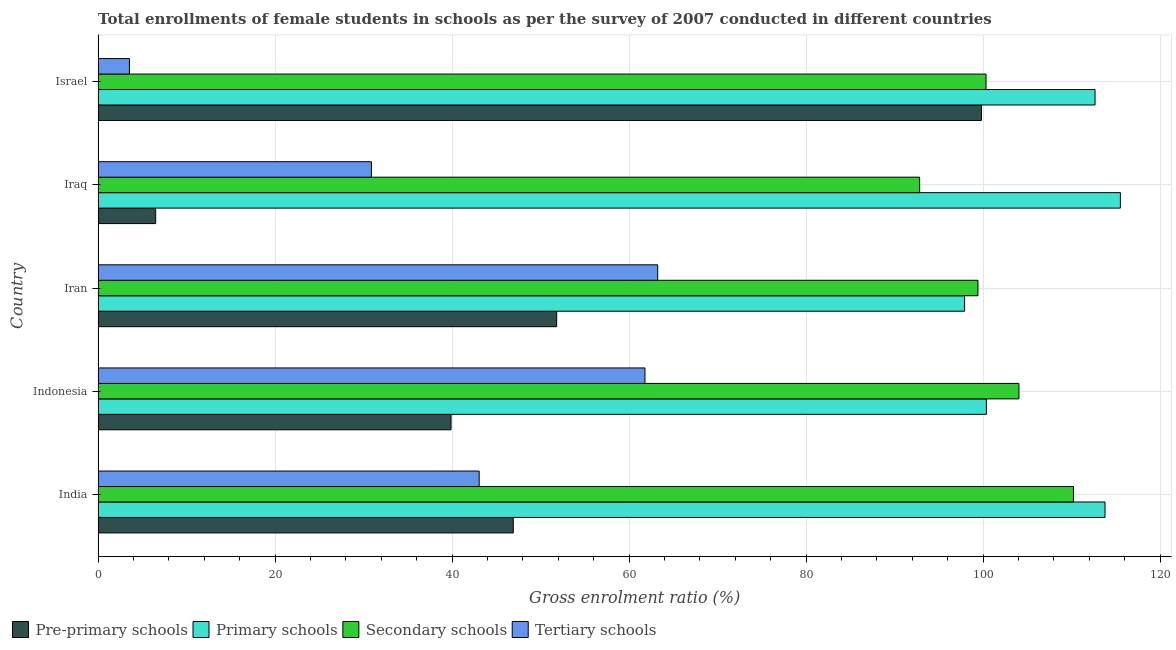Are the number of bars per tick equal to the number of legend labels?
Provide a succinct answer. Yes. Are the number of bars on each tick of the Y-axis equal?
Ensure brevity in your answer.  Yes. How many bars are there on the 2nd tick from the top?
Your response must be concise. 4. What is the label of the 4th group of bars from the top?
Offer a terse response. Indonesia. In how many cases, is the number of bars for a given country not equal to the number of legend labels?
Offer a terse response. 0. What is the gross enrolment ratio(female) in tertiary schools in Iran?
Keep it short and to the point. 63.23. Across all countries, what is the maximum gross enrolment ratio(female) in primary schools?
Your answer should be very brief. 115.51. Across all countries, what is the minimum gross enrolment ratio(female) in tertiary schools?
Offer a terse response. 3.54. In which country was the gross enrolment ratio(female) in primary schools maximum?
Ensure brevity in your answer.  Iraq. What is the total gross enrolment ratio(female) in pre-primary schools in the graph?
Give a very brief answer. 244.92. What is the difference between the gross enrolment ratio(female) in primary schools in India and that in Iran?
Ensure brevity in your answer.  15.87. What is the difference between the gross enrolment ratio(female) in pre-primary schools in Israel and the gross enrolment ratio(female) in secondary schools in Indonesia?
Offer a terse response. -4.23. What is the average gross enrolment ratio(female) in secondary schools per country?
Provide a short and direct response. 101.36. What is the difference between the gross enrolment ratio(female) in tertiary schools and gross enrolment ratio(female) in primary schools in Iraq?
Give a very brief answer. -84.63. In how many countries, is the gross enrolment ratio(female) in secondary schools greater than 80 %?
Keep it short and to the point. 5. What is the ratio of the gross enrolment ratio(female) in pre-primary schools in Indonesia to that in Iran?
Offer a terse response. 0.77. What is the difference between the highest and the second highest gross enrolment ratio(female) in pre-primary schools?
Your answer should be compact. 48. What is the difference between the highest and the lowest gross enrolment ratio(female) in pre-primary schools?
Offer a terse response. 93.31. In how many countries, is the gross enrolment ratio(female) in tertiary schools greater than the average gross enrolment ratio(female) in tertiary schools taken over all countries?
Provide a succinct answer. 3. Is it the case that in every country, the sum of the gross enrolment ratio(female) in secondary schools and gross enrolment ratio(female) in primary schools is greater than the sum of gross enrolment ratio(female) in tertiary schools and gross enrolment ratio(female) in pre-primary schools?
Give a very brief answer. Yes. What does the 1st bar from the top in India represents?
Your answer should be compact. Tertiary schools. What does the 1st bar from the bottom in Iran represents?
Ensure brevity in your answer.  Pre-primary schools. Is it the case that in every country, the sum of the gross enrolment ratio(female) in pre-primary schools and gross enrolment ratio(female) in primary schools is greater than the gross enrolment ratio(female) in secondary schools?
Your answer should be compact. Yes. How many countries are there in the graph?
Your answer should be very brief. 5. What is the difference between two consecutive major ticks on the X-axis?
Keep it short and to the point. 20. Are the values on the major ticks of X-axis written in scientific E-notation?
Ensure brevity in your answer.  No. Does the graph contain any zero values?
Provide a short and direct response. No. Does the graph contain grids?
Provide a succinct answer. Yes. How many legend labels are there?
Ensure brevity in your answer.  4. How are the legend labels stacked?
Offer a terse response. Horizontal. What is the title of the graph?
Your response must be concise. Total enrollments of female students in schools as per the survey of 2007 conducted in different countries. Does "International Monetary Fund" appear as one of the legend labels in the graph?
Make the answer very short. No. What is the label or title of the X-axis?
Give a very brief answer. Gross enrolment ratio (%). What is the label or title of the Y-axis?
Offer a terse response. Country. What is the Gross enrolment ratio (%) of Pre-primary schools in India?
Provide a succinct answer. 46.91. What is the Gross enrolment ratio (%) of Primary schools in India?
Provide a succinct answer. 113.77. What is the Gross enrolment ratio (%) in Secondary schools in India?
Provide a short and direct response. 110.21. What is the Gross enrolment ratio (%) in Tertiary schools in India?
Give a very brief answer. 43.06. What is the Gross enrolment ratio (%) in Pre-primary schools in Indonesia?
Provide a succinct answer. 39.88. What is the Gross enrolment ratio (%) in Primary schools in Indonesia?
Your answer should be compact. 100.37. What is the Gross enrolment ratio (%) in Secondary schools in Indonesia?
Your answer should be compact. 104.05. What is the Gross enrolment ratio (%) of Tertiary schools in Indonesia?
Your answer should be compact. 61.79. What is the Gross enrolment ratio (%) of Pre-primary schools in Iran?
Give a very brief answer. 51.81. What is the Gross enrolment ratio (%) of Primary schools in Iran?
Provide a succinct answer. 97.91. What is the Gross enrolment ratio (%) of Secondary schools in Iran?
Give a very brief answer. 99.42. What is the Gross enrolment ratio (%) of Tertiary schools in Iran?
Your answer should be very brief. 63.23. What is the Gross enrolment ratio (%) in Pre-primary schools in Iraq?
Offer a very short reply. 6.51. What is the Gross enrolment ratio (%) of Primary schools in Iraq?
Keep it short and to the point. 115.51. What is the Gross enrolment ratio (%) of Secondary schools in Iraq?
Your answer should be compact. 92.83. What is the Gross enrolment ratio (%) in Tertiary schools in Iraq?
Provide a succinct answer. 30.88. What is the Gross enrolment ratio (%) in Pre-primary schools in Israel?
Give a very brief answer. 99.81. What is the Gross enrolment ratio (%) of Primary schools in Israel?
Offer a very short reply. 112.65. What is the Gross enrolment ratio (%) in Secondary schools in Israel?
Ensure brevity in your answer.  100.33. What is the Gross enrolment ratio (%) in Tertiary schools in Israel?
Ensure brevity in your answer.  3.54. Across all countries, what is the maximum Gross enrolment ratio (%) in Pre-primary schools?
Your response must be concise. 99.81. Across all countries, what is the maximum Gross enrolment ratio (%) in Primary schools?
Your answer should be compact. 115.51. Across all countries, what is the maximum Gross enrolment ratio (%) in Secondary schools?
Make the answer very short. 110.21. Across all countries, what is the maximum Gross enrolment ratio (%) of Tertiary schools?
Ensure brevity in your answer.  63.23. Across all countries, what is the minimum Gross enrolment ratio (%) in Pre-primary schools?
Ensure brevity in your answer.  6.51. Across all countries, what is the minimum Gross enrolment ratio (%) of Primary schools?
Offer a terse response. 97.91. Across all countries, what is the minimum Gross enrolment ratio (%) of Secondary schools?
Give a very brief answer. 92.83. Across all countries, what is the minimum Gross enrolment ratio (%) of Tertiary schools?
Make the answer very short. 3.54. What is the total Gross enrolment ratio (%) of Pre-primary schools in the graph?
Make the answer very short. 244.92. What is the total Gross enrolment ratio (%) of Primary schools in the graph?
Your answer should be very brief. 540.2. What is the total Gross enrolment ratio (%) of Secondary schools in the graph?
Offer a terse response. 506.82. What is the total Gross enrolment ratio (%) of Tertiary schools in the graph?
Give a very brief answer. 202.5. What is the difference between the Gross enrolment ratio (%) in Pre-primary schools in India and that in Indonesia?
Your answer should be compact. 7.03. What is the difference between the Gross enrolment ratio (%) in Primary schools in India and that in Indonesia?
Make the answer very short. 13.41. What is the difference between the Gross enrolment ratio (%) in Secondary schools in India and that in Indonesia?
Provide a short and direct response. 6.16. What is the difference between the Gross enrolment ratio (%) of Tertiary schools in India and that in Indonesia?
Offer a terse response. -18.73. What is the difference between the Gross enrolment ratio (%) of Pre-primary schools in India and that in Iran?
Ensure brevity in your answer.  -4.9. What is the difference between the Gross enrolment ratio (%) in Primary schools in India and that in Iran?
Offer a very short reply. 15.87. What is the difference between the Gross enrolment ratio (%) in Secondary schools in India and that in Iran?
Your response must be concise. 10.79. What is the difference between the Gross enrolment ratio (%) of Tertiary schools in India and that in Iran?
Ensure brevity in your answer.  -20.17. What is the difference between the Gross enrolment ratio (%) of Pre-primary schools in India and that in Iraq?
Offer a terse response. 40.41. What is the difference between the Gross enrolment ratio (%) in Primary schools in India and that in Iraq?
Your response must be concise. -1.74. What is the difference between the Gross enrolment ratio (%) of Secondary schools in India and that in Iraq?
Your response must be concise. 17.38. What is the difference between the Gross enrolment ratio (%) in Tertiary schools in India and that in Iraq?
Offer a terse response. 12.18. What is the difference between the Gross enrolment ratio (%) of Pre-primary schools in India and that in Israel?
Your answer should be compact. -52.9. What is the difference between the Gross enrolment ratio (%) of Primary schools in India and that in Israel?
Give a very brief answer. 1.13. What is the difference between the Gross enrolment ratio (%) in Secondary schools in India and that in Israel?
Provide a succinct answer. 9.88. What is the difference between the Gross enrolment ratio (%) of Tertiary schools in India and that in Israel?
Offer a very short reply. 39.52. What is the difference between the Gross enrolment ratio (%) of Pre-primary schools in Indonesia and that in Iran?
Offer a very short reply. -11.94. What is the difference between the Gross enrolment ratio (%) of Primary schools in Indonesia and that in Iran?
Offer a terse response. 2.46. What is the difference between the Gross enrolment ratio (%) of Secondary schools in Indonesia and that in Iran?
Give a very brief answer. 4.63. What is the difference between the Gross enrolment ratio (%) of Tertiary schools in Indonesia and that in Iran?
Provide a succinct answer. -1.44. What is the difference between the Gross enrolment ratio (%) of Pre-primary schools in Indonesia and that in Iraq?
Your answer should be very brief. 33.37. What is the difference between the Gross enrolment ratio (%) of Primary schools in Indonesia and that in Iraq?
Offer a very short reply. -15.14. What is the difference between the Gross enrolment ratio (%) in Secondary schools in Indonesia and that in Iraq?
Your response must be concise. 11.22. What is the difference between the Gross enrolment ratio (%) in Tertiary schools in Indonesia and that in Iraq?
Your answer should be very brief. 30.91. What is the difference between the Gross enrolment ratio (%) in Pre-primary schools in Indonesia and that in Israel?
Your answer should be very brief. -59.93. What is the difference between the Gross enrolment ratio (%) of Primary schools in Indonesia and that in Israel?
Provide a short and direct response. -12.28. What is the difference between the Gross enrolment ratio (%) of Secondary schools in Indonesia and that in Israel?
Give a very brief answer. 3.72. What is the difference between the Gross enrolment ratio (%) of Tertiary schools in Indonesia and that in Israel?
Offer a very short reply. 58.25. What is the difference between the Gross enrolment ratio (%) of Pre-primary schools in Iran and that in Iraq?
Offer a very short reply. 45.31. What is the difference between the Gross enrolment ratio (%) of Primary schools in Iran and that in Iraq?
Offer a very short reply. -17.6. What is the difference between the Gross enrolment ratio (%) of Secondary schools in Iran and that in Iraq?
Keep it short and to the point. 6.59. What is the difference between the Gross enrolment ratio (%) in Tertiary schools in Iran and that in Iraq?
Your response must be concise. 32.35. What is the difference between the Gross enrolment ratio (%) in Pre-primary schools in Iran and that in Israel?
Your response must be concise. -48. What is the difference between the Gross enrolment ratio (%) in Primary schools in Iran and that in Israel?
Your answer should be compact. -14.74. What is the difference between the Gross enrolment ratio (%) in Secondary schools in Iran and that in Israel?
Your answer should be very brief. -0.91. What is the difference between the Gross enrolment ratio (%) of Tertiary schools in Iran and that in Israel?
Your response must be concise. 59.69. What is the difference between the Gross enrolment ratio (%) of Pre-primary schools in Iraq and that in Israel?
Provide a succinct answer. -93.31. What is the difference between the Gross enrolment ratio (%) of Primary schools in Iraq and that in Israel?
Offer a very short reply. 2.86. What is the difference between the Gross enrolment ratio (%) of Secondary schools in Iraq and that in Israel?
Make the answer very short. -7.5. What is the difference between the Gross enrolment ratio (%) of Tertiary schools in Iraq and that in Israel?
Make the answer very short. 27.34. What is the difference between the Gross enrolment ratio (%) in Pre-primary schools in India and the Gross enrolment ratio (%) in Primary schools in Indonesia?
Your response must be concise. -53.45. What is the difference between the Gross enrolment ratio (%) in Pre-primary schools in India and the Gross enrolment ratio (%) in Secondary schools in Indonesia?
Keep it short and to the point. -57.13. What is the difference between the Gross enrolment ratio (%) in Pre-primary schools in India and the Gross enrolment ratio (%) in Tertiary schools in Indonesia?
Your response must be concise. -14.88. What is the difference between the Gross enrolment ratio (%) in Primary schools in India and the Gross enrolment ratio (%) in Secondary schools in Indonesia?
Your answer should be very brief. 9.73. What is the difference between the Gross enrolment ratio (%) in Primary schools in India and the Gross enrolment ratio (%) in Tertiary schools in Indonesia?
Keep it short and to the point. 51.98. What is the difference between the Gross enrolment ratio (%) in Secondary schools in India and the Gross enrolment ratio (%) in Tertiary schools in Indonesia?
Make the answer very short. 48.42. What is the difference between the Gross enrolment ratio (%) of Pre-primary schools in India and the Gross enrolment ratio (%) of Primary schools in Iran?
Offer a terse response. -50.99. What is the difference between the Gross enrolment ratio (%) of Pre-primary schools in India and the Gross enrolment ratio (%) of Secondary schools in Iran?
Offer a very short reply. -52.51. What is the difference between the Gross enrolment ratio (%) in Pre-primary schools in India and the Gross enrolment ratio (%) in Tertiary schools in Iran?
Provide a succinct answer. -16.32. What is the difference between the Gross enrolment ratio (%) of Primary schools in India and the Gross enrolment ratio (%) of Secondary schools in Iran?
Your response must be concise. 14.36. What is the difference between the Gross enrolment ratio (%) of Primary schools in India and the Gross enrolment ratio (%) of Tertiary schools in Iran?
Keep it short and to the point. 50.54. What is the difference between the Gross enrolment ratio (%) in Secondary schools in India and the Gross enrolment ratio (%) in Tertiary schools in Iran?
Offer a very short reply. 46.98. What is the difference between the Gross enrolment ratio (%) in Pre-primary schools in India and the Gross enrolment ratio (%) in Primary schools in Iraq?
Your answer should be compact. -68.6. What is the difference between the Gross enrolment ratio (%) in Pre-primary schools in India and the Gross enrolment ratio (%) in Secondary schools in Iraq?
Provide a short and direct response. -45.91. What is the difference between the Gross enrolment ratio (%) of Pre-primary schools in India and the Gross enrolment ratio (%) of Tertiary schools in Iraq?
Ensure brevity in your answer.  16.03. What is the difference between the Gross enrolment ratio (%) in Primary schools in India and the Gross enrolment ratio (%) in Secondary schools in Iraq?
Your answer should be very brief. 20.95. What is the difference between the Gross enrolment ratio (%) in Primary schools in India and the Gross enrolment ratio (%) in Tertiary schools in Iraq?
Ensure brevity in your answer.  82.89. What is the difference between the Gross enrolment ratio (%) of Secondary schools in India and the Gross enrolment ratio (%) of Tertiary schools in Iraq?
Give a very brief answer. 79.33. What is the difference between the Gross enrolment ratio (%) in Pre-primary schools in India and the Gross enrolment ratio (%) in Primary schools in Israel?
Make the answer very short. -65.73. What is the difference between the Gross enrolment ratio (%) of Pre-primary schools in India and the Gross enrolment ratio (%) of Secondary schools in Israel?
Offer a very short reply. -53.42. What is the difference between the Gross enrolment ratio (%) of Pre-primary schools in India and the Gross enrolment ratio (%) of Tertiary schools in Israel?
Your answer should be very brief. 43.37. What is the difference between the Gross enrolment ratio (%) in Primary schools in India and the Gross enrolment ratio (%) in Secondary schools in Israel?
Ensure brevity in your answer.  13.44. What is the difference between the Gross enrolment ratio (%) in Primary schools in India and the Gross enrolment ratio (%) in Tertiary schools in Israel?
Offer a very short reply. 110.23. What is the difference between the Gross enrolment ratio (%) of Secondary schools in India and the Gross enrolment ratio (%) of Tertiary schools in Israel?
Provide a short and direct response. 106.67. What is the difference between the Gross enrolment ratio (%) in Pre-primary schools in Indonesia and the Gross enrolment ratio (%) in Primary schools in Iran?
Keep it short and to the point. -58.03. What is the difference between the Gross enrolment ratio (%) of Pre-primary schools in Indonesia and the Gross enrolment ratio (%) of Secondary schools in Iran?
Give a very brief answer. -59.54. What is the difference between the Gross enrolment ratio (%) of Pre-primary schools in Indonesia and the Gross enrolment ratio (%) of Tertiary schools in Iran?
Your answer should be compact. -23.35. What is the difference between the Gross enrolment ratio (%) of Primary schools in Indonesia and the Gross enrolment ratio (%) of Secondary schools in Iran?
Your response must be concise. 0.95. What is the difference between the Gross enrolment ratio (%) of Primary schools in Indonesia and the Gross enrolment ratio (%) of Tertiary schools in Iran?
Your answer should be very brief. 37.14. What is the difference between the Gross enrolment ratio (%) in Secondary schools in Indonesia and the Gross enrolment ratio (%) in Tertiary schools in Iran?
Give a very brief answer. 40.82. What is the difference between the Gross enrolment ratio (%) in Pre-primary schools in Indonesia and the Gross enrolment ratio (%) in Primary schools in Iraq?
Make the answer very short. -75.63. What is the difference between the Gross enrolment ratio (%) of Pre-primary schools in Indonesia and the Gross enrolment ratio (%) of Secondary schools in Iraq?
Offer a very short reply. -52.95. What is the difference between the Gross enrolment ratio (%) of Pre-primary schools in Indonesia and the Gross enrolment ratio (%) of Tertiary schools in Iraq?
Offer a terse response. 9. What is the difference between the Gross enrolment ratio (%) of Primary schools in Indonesia and the Gross enrolment ratio (%) of Secondary schools in Iraq?
Offer a terse response. 7.54. What is the difference between the Gross enrolment ratio (%) in Primary schools in Indonesia and the Gross enrolment ratio (%) in Tertiary schools in Iraq?
Give a very brief answer. 69.49. What is the difference between the Gross enrolment ratio (%) of Secondary schools in Indonesia and the Gross enrolment ratio (%) of Tertiary schools in Iraq?
Make the answer very short. 73.16. What is the difference between the Gross enrolment ratio (%) in Pre-primary schools in Indonesia and the Gross enrolment ratio (%) in Primary schools in Israel?
Keep it short and to the point. -72.77. What is the difference between the Gross enrolment ratio (%) of Pre-primary schools in Indonesia and the Gross enrolment ratio (%) of Secondary schools in Israel?
Provide a short and direct response. -60.45. What is the difference between the Gross enrolment ratio (%) of Pre-primary schools in Indonesia and the Gross enrolment ratio (%) of Tertiary schools in Israel?
Provide a succinct answer. 36.34. What is the difference between the Gross enrolment ratio (%) in Primary schools in Indonesia and the Gross enrolment ratio (%) in Secondary schools in Israel?
Keep it short and to the point. 0.04. What is the difference between the Gross enrolment ratio (%) of Primary schools in Indonesia and the Gross enrolment ratio (%) of Tertiary schools in Israel?
Your answer should be very brief. 96.83. What is the difference between the Gross enrolment ratio (%) in Secondary schools in Indonesia and the Gross enrolment ratio (%) in Tertiary schools in Israel?
Give a very brief answer. 100.51. What is the difference between the Gross enrolment ratio (%) in Pre-primary schools in Iran and the Gross enrolment ratio (%) in Primary schools in Iraq?
Offer a very short reply. -63.69. What is the difference between the Gross enrolment ratio (%) in Pre-primary schools in Iran and the Gross enrolment ratio (%) in Secondary schools in Iraq?
Your response must be concise. -41.01. What is the difference between the Gross enrolment ratio (%) of Pre-primary schools in Iran and the Gross enrolment ratio (%) of Tertiary schools in Iraq?
Keep it short and to the point. 20.93. What is the difference between the Gross enrolment ratio (%) of Primary schools in Iran and the Gross enrolment ratio (%) of Secondary schools in Iraq?
Give a very brief answer. 5.08. What is the difference between the Gross enrolment ratio (%) of Primary schools in Iran and the Gross enrolment ratio (%) of Tertiary schools in Iraq?
Ensure brevity in your answer.  67.02. What is the difference between the Gross enrolment ratio (%) in Secondary schools in Iran and the Gross enrolment ratio (%) in Tertiary schools in Iraq?
Offer a very short reply. 68.54. What is the difference between the Gross enrolment ratio (%) of Pre-primary schools in Iran and the Gross enrolment ratio (%) of Primary schools in Israel?
Offer a terse response. -60.83. What is the difference between the Gross enrolment ratio (%) of Pre-primary schools in Iran and the Gross enrolment ratio (%) of Secondary schools in Israel?
Keep it short and to the point. -48.52. What is the difference between the Gross enrolment ratio (%) of Pre-primary schools in Iran and the Gross enrolment ratio (%) of Tertiary schools in Israel?
Provide a short and direct response. 48.27. What is the difference between the Gross enrolment ratio (%) of Primary schools in Iran and the Gross enrolment ratio (%) of Secondary schools in Israel?
Your answer should be compact. -2.42. What is the difference between the Gross enrolment ratio (%) in Primary schools in Iran and the Gross enrolment ratio (%) in Tertiary schools in Israel?
Offer a very short reply. 94.37. What is the difference between the Gross enrolment ratio (%) in Secondary schools in Iran and the Gross enrolment ratio (%) in Tertiary schools in Israel?
Your response must be concise. 95.88. What is the difference between the Gross enrolment ratio (%) in Pre-primary schools in Iraq and the Gross enrolment ratio (%) in Primary schools in Israel?
Your answer should be very brief. -106.14. What is the difference between the Gross enrolment ratio (%) in Pre-primary schools in Iraq and the Gross enrolment ratio (%) in Secondary schools in Israel?
Offer a very short reply. -93.82. What is the difference between the Gross enrolment ratio (%) in Pre-primary schools in Iraq and the Gross enrolment ratio (%) in Tertiary schools in Israel?
Offer a very short reply. 2.97. What is the difference between the Gross enrolment ratio (%) of Primary schools in Iraq and the Gross enrolment ratio (%) of Secondary schools in Israel?
Offer a terse response. 15.18. What is the difference between the Gross enrolment ratio (%) of Primary schools in Iraq and the Gross enrolment ratio (%) of Tertiary schools in Israel?
Ensure brevity in your answer.  111.97. What is the difference between the Gross enrolment ratio (%) of Secondary schools in Iraq and the Gross enrolment ratio (%) of Tertiary schools in Israel?
Ensure brevity in your answer.  89.29. What is the average Gross enrolment ratio (%) of Pre-primary schools per country?
Offer a terse response. 48.98. What is the average Gross enrolment ratio (%) in Primary schools per country?
Ensure brevity in your answer.  108.04. What is the average Gross enrolment ratio (%) of Secondary schools per country?
Ensure brevity in your answer.  101.36. What is the average Gross enrolment ratio (%) in Tertiary schools per country?
Offer a very short reply. 40.5. What is the difference between the Gross enrolment ratio (%) of Pre-primary schools and Gross enrolment ratio (%) of Primary schools in India?
Provide a succinct answer. -66.86. What is the difference between the Gross enrolment ratio (%) in Pre-primary schools and Gross enrolment ratio (%) in Secondary schools in India?
Offer a very short reply. -63.3. What is the difference between the Gross enrolment ratio (%) of Pre-primary schools and Gross enrolment ratio (%) of Tertiary schools in India?
Provide a succinct answer. 3.85. What is the difference between the Gross enrolment ratio (%) of Primary schools and Gross enrolment ratio (%) of Secondary schools in India?
Your response must be concise. 3.57. What is the difference between the Gross enrolment ratio (%) of Primary schools and Gross enrolment ratio (%) of Tertiary schools in India?
Offer a very short reply. 70.72. What is the difference between the Gross enrolment ratio (%) of Secondary schools and Gross enrolment ratio (%) of Tertiary schools in India?
Your answer should be very brief. 67.15. What is the difference between the Gross enrolment ratio (%) of Pre-primary schools and Gross enrolment ratio (%) of Primary schools in Indonesia?
Your answer should be compact. -60.49. What is the difference between the Gross enrolment ratio (%) in Pre-primary schools and Gross enrolment ratio (%) in Secondary schools in Indonesia?
Provide a succinct answer. -64.17. What is the difference between the Gross enrolment ratio (%) of Pre-primary schools and Gross enrolment ratio (%) of Tertiary schools in Indonesia?
Make the answer very short. -21.91. What is the difference between the Gross enrolment ratio (%) in Primary schools and Gross enrolment ratio (%) in Secondary schools in Indonesia?
Offer a terse response. -3.68. What is the difference between the Gross enrolment ratio (%) in Primary schools and Gross enrolment ratio (%) in Tertiary schools in Indonesia?
Give a very brief answer. 38.58. What is the difference between the Gross enrolment ratio (%) in Secondary schools and Gross enrolment ratio (%) in Tertiary schools in Indonesia?
Provide a succinct answer. 42.25. What is the difference between the Gross enrolment ratio (%) in Pre-primary schools and Gross enrolment ratio (%) in Primary schools in Iran?
Your answer should be compact. -46.09. What is the difference between the Gross enrolment ratio (%) of Pre-primary schools and Gross enrolment ratio (%) of Secondary schools in Iran?
Give a very brief answer. -47.6. What is the difference between the Gross enrolment ratio (%) of Pre-primary schools and Gross enrolment ratio (%) of Tertiary schools in Iran?
Your response must be concise. -11.42. What is the difference between the Gross enrolment ratio (%) in Primary schools and Gross enrolment ratio (%) in Secondary schools in Iran?
Offer a very short reply. -1.51. What is the difference between the Gross enrolment ratio (%) in Primary schools and Gross enrolment ratio (%) in Tertiary schools in Iran?
Keep it short and to the point. 34.68. What is the difference between the Gross enrolment ratio (%) of Secondary schools and Gross enrolment ratio (%) of Tertiary schools in Iran?
Offer a very short reply. 36.19. What is the difference between the Gross enrolment ratio (%) of Pre-primary schools and Gross enrolment ratio (%) of Primary schools in Iraq?
Provide a succinct answer. -109. What is the difference between the Gross enrolment ratio (%) of Pre-primary schools and Gross enrolment ratio (%) of Secondary schools in Iraq?
Provide a succinct answer. -86.32. What is the difference between the Gross enrolment ratio (%) of Pre-primary schools and Gross enrolment ratio (%) of Tertiary schools in Iraq?
Your response must be concise. -24.38. What is the difference between the Gross enrolment ratio (%) of Primary schools and Gross enrolment ratio (%) of Secondary schools in Iraq?
Offer a very short reply. 22.68. What is the difference between the Gross enrolment ratio (%) in Primary schools and Gross enrolment ratio (%) in Tertiary schools in Iraq?
Offer a terse response. 84.63. What is the difference between the Gross enrolment ratio (%) in Secondary schools and Gross enrolment ratio (%) in Tertiary schools in Iraq?
Your response must be concise. 61.95. What is the difference between the Gross enrolment ratio (%) in Pre-primary schools and Gross enrolment ratio (%) in Primary schools in Israel?
Your answer should be very brief. -12.83. What is the difference between the Gross enrolment ratio (%) in Pre-primary schools and Gross enrolment ratio (%) in Secondary schools in Israel?
Offer a terse response. -0.52. What is the difference between the Gross enrolment ratio (%) in Pre-primary schools and Gross enrolment ratio (%) in Tertiary schools in Israel?
Your answer should be very brief. 96.27. What is the difference between the Gross enrolment ratio (%) in Primary schools and Gross enrolment ratio (%) in Secondary schools in Israel?
Ensure brevity in your answer.  12.32. What is the difference between the Gross enrolment ratio (%) of Primary schools and Gross enrolment ratio (%) of Tertiary schools in Israel?
Your answer should be very brief. 109.11. What is the difference between the Gross enrolment ratio (%) in Secondary schools and Gross enrolment ratio (%) in Tertiary schools in Israel?
Provide a succinct answer. 96.79. What is the ratio of the Gross enrolment ratio (%) of Pre-primary schools in India to that in Indonesia?
Give a very brief answer. 1.18. What is the ratio of the Gross enrolment ratio (%) in Primary schools in India to that in Indonesia?
Keep it short and to the point. 1.13. What is the ratio of the Gross enrolment ratio (%) in Secondary schools in India to that in Indonesia?
Your answer should be very brief. 1.06. What is the ratio of the Gross enrolment ratio (%) of Tertiary schools in India to that in Indonesia?
Give a very brief answer. 0.7. What is the ratio of the Gross enrolment ratio (%) of Pre-primary schools in India to that in Iran?
Provide a succinct answer. 0.91. What is the ratio of the Gross enrolment ratio (%) in Primary schools in India to that in Iran?
Your answer should be very brief. 1.16. What is the ratio of the Gross enrolment ratio (%) in Secondary schools in India to that in Iran?
Provide a short and direct response. 1.11. What is the ratio of the Gross enrolment ratio (%) of Tertiary schools in India to that in Iran?
Give a very brief answer. 0.68. What is the ratio of the Gross enrolment ratio (%) of Pre-primary schools in India to that in Iraq?
Provide a short and direct response. 7.21. What is the ratio of the Gross enrolment ratio (%) of Secondary schools in India to that in Iraq?
Ensure brevity in your answer.  1.19. What is the ratio of the Gross enrolment ratio (%) of Tertiary schools in India to that in Iraq?
Give a very brief answer. 1.39. What is the ratio of the Gross enrolment ratio (%) of Pre-primary schools in India to that in Israel?
Offer a terse response. 0.47. What is the ratio of the Gross enrolment ratio (%) of Secondary schools in India to that in Israel?
Provide a succinct answer. 1.1. What is the ratio of the Gross enrolment ratio (%) in Tertiary schools in India to that in Israel?
Provide a succinct answer. 12.17. What is the ratio of the Gross enrolment ratio (%) in Pre-primary schools in Indonesia to that in Iran?
Your answer should be compact. 0.77. What is the ratio of the Gross enrolment ratio (%) of Primary schools in Indonesia to that in Iran?
Provide a succinct answer. 1.03. What is the ratio of the Gross enrolment ratio (%) in Secondary schools in Indonesia to that in Iran?
Provide a succinct answer. 1.05. What is the ratio of the Gross enrolment ratio (%) in Tertiary schools in Indonesia to that in Iran?
Ensure brevity in your answer.  0.98. What is the ratio of the Gross enrolment ratio (%) of Pre-primary schools in Indonesia to that in Iraq?
Offer a very short reply. 6.13. What is the ratio of the Gross enrolment ratio (%) of Primary schools in Indonesia to that in Iraq?
Keep it short and to the point. 0.87. What is the ratio of the Gross enrolment ratio (%) of Secondary schools in Indonesia to that in Iraq?
Make the answer very short. 1.12. What is the ratio of the Gross enrolment ratio (%) of Tertiary schools in Indonesia to that in Iraq?
Keep it short and to the point. 2. What is the ratio of the Gross enrolment ratio (%) in Pre-primary schools in Indonesia to that in Israel?
Offer a terse response. 0.4. What is the ratio of the Gross enrolment ratio (%) in Primary schools in Indonesia to that in Israel?
Ensure brevity in your answer.  0.89. What is the ratio of the Gross enrolment ratio (%) of Secondary schools in Indonesia to that in Israel?
Your answer should be very brief. 1.04. What is the ratio of the Gross enrolment ratio (%) in Tertiary schools in Indonesia to that in Israel?
Your answer should be very brief. 17.46. What is the ratio of the Gross enrolment ratio (%) in Pre-primary schools in Iran to that in Iraq?
Your answer should be compact. 7.96. What is the ratio of the Gross enrolment ratio (%) in Primary schools in Iran to that in Iraq?
Ensure brevity in your answer.  0.85. What is the ratio of the Gross enrolment ratio (%) of Secondary schools in Iran to that in Iraq?
Give a very brief answer. 1.07. What is the ratio of the Gross enrolment ratio (%) of Tertiary schools in Iran to that in Iraq?
Give a very brief answer. 2.05. What is the ratio of the Gross enrolment ratio (%) in Pre-primary schools in Iran to that in Israel?
Give a very brief answer. 0.52. What is the ratio of the Gross enrolment ratio (%) in Primary schools in Iran to that in Israel?
Offer a very short reply. 0.87. What is the ratio of the Gross enrolment ratio (%) in Secondary schools in Iran to that in Israel?
Offer a very short reply. 0.99. What is the ratio of the Gross enrolment ratio (%) in Tertiary schools in Iran to that in Israel?
Offer a terse response. 17.87. What is the ratio of the Gross enrolment ratio (%) in Pre-primary schools in Iraq to that in Israel?
Offer a very short reply. 0.07. What is the ratio of the Gross enrolment ratio (%) in Primary schools in Iraq to that in Israel?
Ensure brevity in your answer.  1.03. What is the ratio of the Gross enrolment ratio (%) in Secondary schools in Iraq to that in Israel?
Make the answer very short. 0.93. What is the ratio of the Gross enrolment ratio (%) in Tertiary schools in Iraq to that in Israel?
Your answer should be very brief. 8.73. What is the difference between the highest and the second highest Gross enrolment ratio (%) of Pre-primary schools?
Offer a terse response. 48. What is the difference between the highest and the second highest Gross enrolment ratio (%) of Primary schools?
Your answer should be very brief. 1.74. What is the difference between the highest and the second highest Gross enrolment ratio (%) in Secondary schools?
Your answer should be very brief. 6.16. What is the difference between the highest and the second highest Gross enrolment ratio (%) in Tertiary schools?
Ensure brevity in your answer.  1.44. What is the difference between the highest and the lowest Gross enrolment ratio (%) in Pre-primary schools?
Ensure brevity in your answer.  93.31. What is the difference between the highest and the lowest Gross enrolment ratio (%) in Primary schools?
Your answer should be very brief. 17.6. What is the difference between the highest and the lowest Gross enrolment ratio (%) of Secondary schools?
Offer a terse response. 17.38. What is the difference between the highest and the lowest Gross enrolment ratio (%) of Tertiary schools?
Your answer should be very brief. 59.69. 